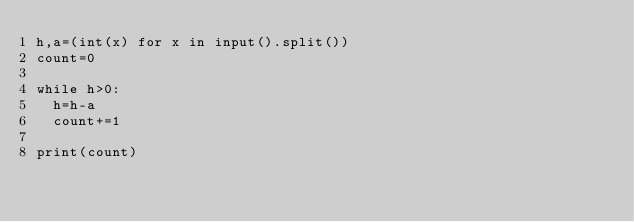<code> <loc_0><loc_0><loc_500><loc_500><_Python_>h,a=(int(x) for x in input().split())
count=0

while h>0:
	h=h-a
	count+=1
	
print(count)</code> 